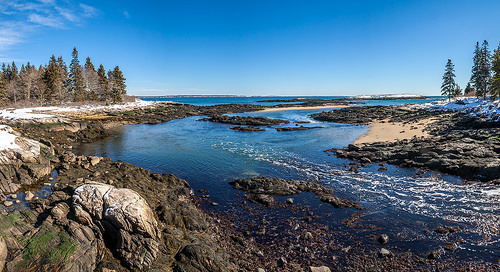<image>
Is there a sky behind the tree? Yes. From this viewpoint, the sky is positioned behind the tree, with the tree partially or fully occluding the sky. Where is the rock in relation to the water? Is it next to the water? Yes. The rock is positioned adjacent to the water, located nearby in the same general area. 